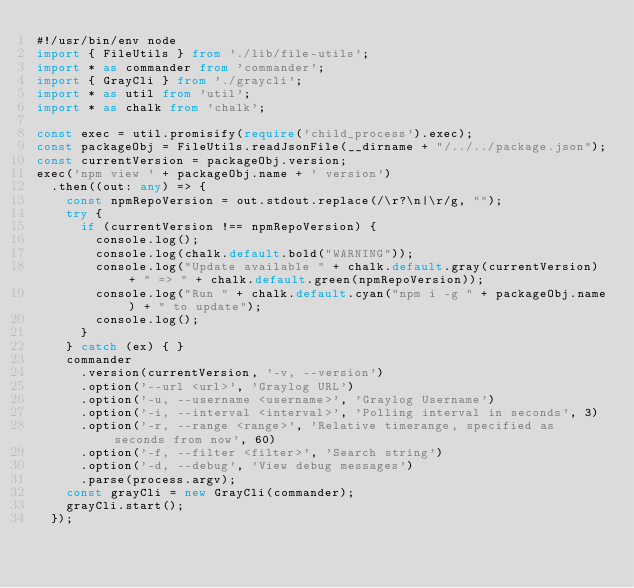<code> <loc_0><loc_0><loc_500><loc_500><_TypeScript_>#!/usr/bin/env node
import { FileUtils } from './lib/file-utils';
import * as commander from 'commander';
import { GrayCli } from './graycli';
import * as util from 'util';
import * as chalk from 'chalk';

const exec = util.promisify(require('child_process').exec);
const packageObj = FileUtils.readJsonFile(__dirname + "/../../package.json");
const currentVersion = packageObj.version;
exec('npm view ' + packageObj.name + ' version')
  .then((out: any) => {
    const npmRepoVersion = out.stdout.replace(/\r?\n|\r/g, "");
    try {
      if (currentVersion !== npmRepoVersion) {
        console.log();
        console.log(chalk.default.bold("WARNING"));
        console.log("Update available " + chalk.default.gray(currentVersion) + " => " + chalk.default.green(npmRepoVersion));
        console.log("Run " + chalk.default.cyan("npm i -g " + packageObj.name) + " to update");
        console.log();
      }
    } catch (ex) { }
    commander
      .version(currentVersion, '-v, --version')
      .option('--url <url>', 'Graylog URL')
      .option('-u, --username <username>', 'Graylog Username')
      .option('-i, --interval <interval>', 'Polling interval in seconds', 3)
      .option('-r, --range <range>', 'Relative timerange, specified as seconds from now', 60)
      .option('-f, --filter <filter>', 'Search string')
      .option('-d, --debug', 'View debug messages')
      .parse(process.argv);
    const grayCli = new GrayCli(commander);
    grayCli.start();
  });

</code> 